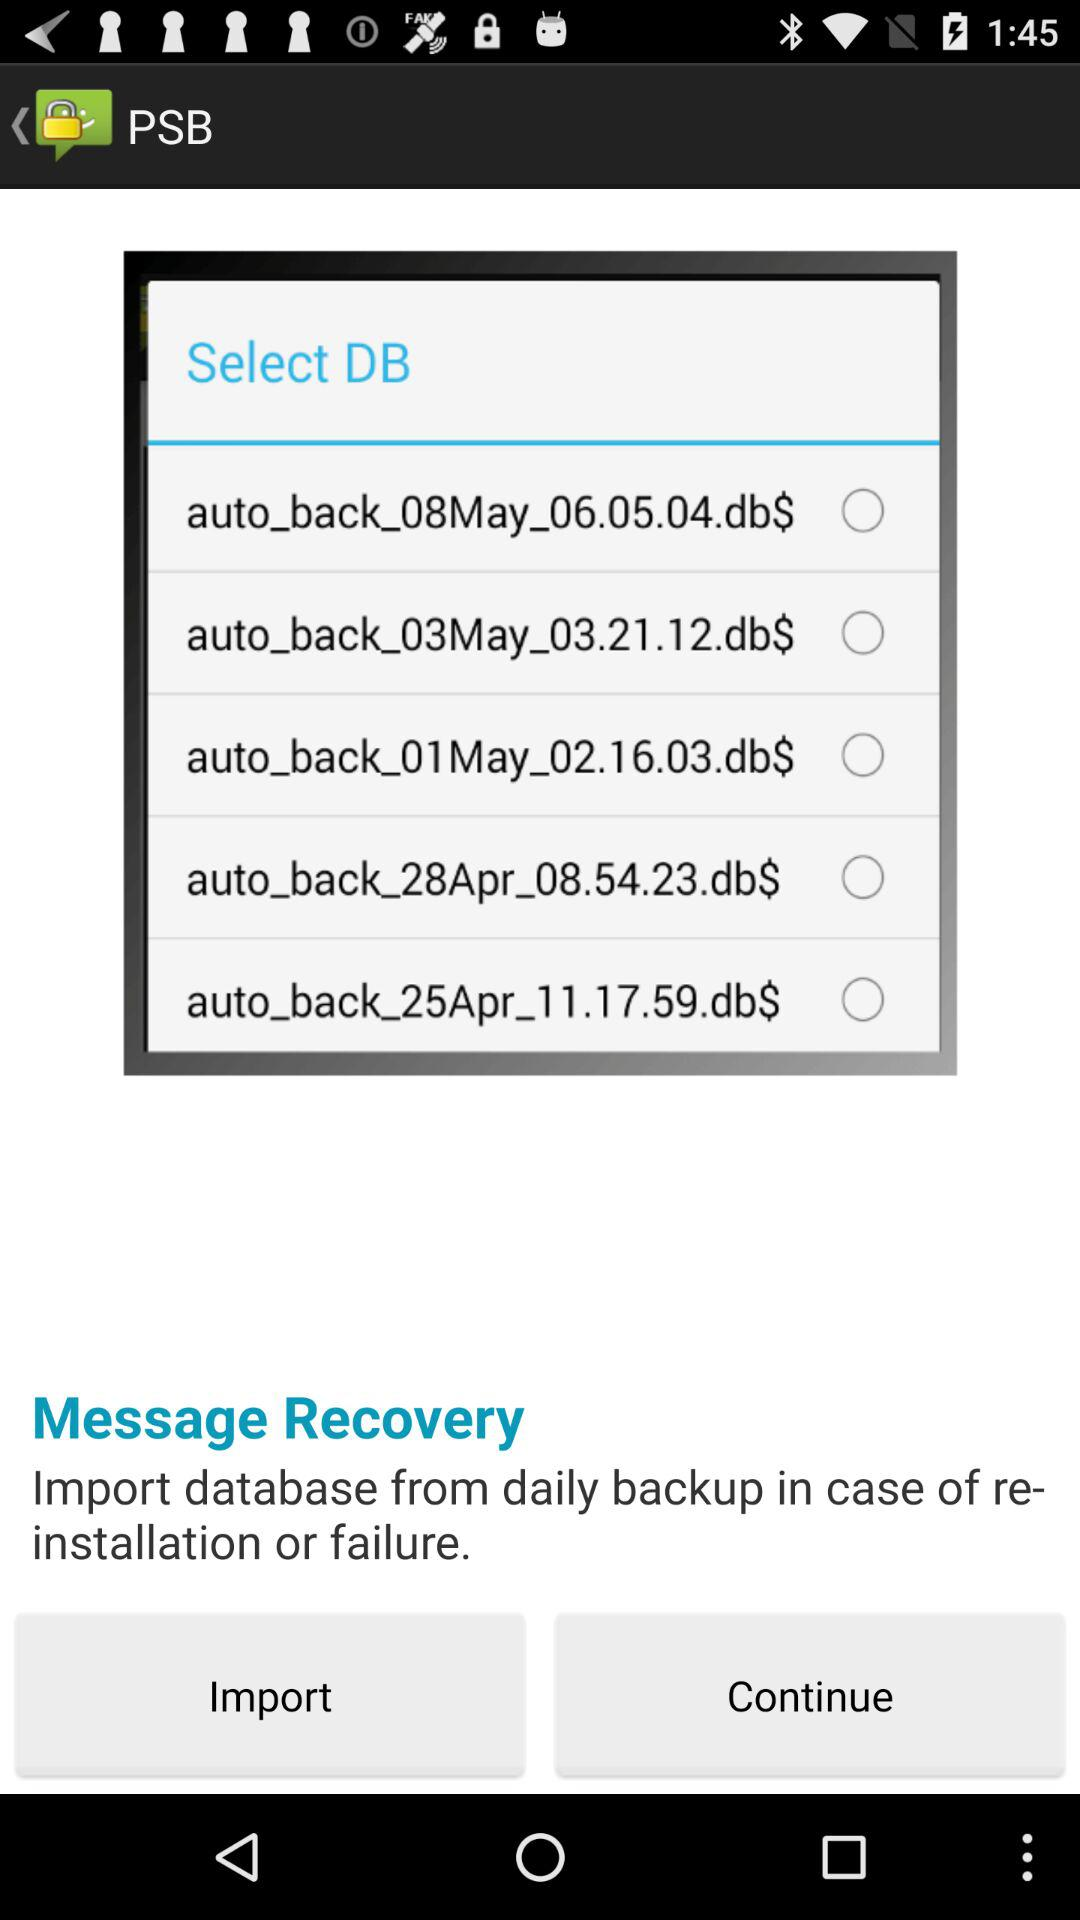Is there a pattern to the days backups are taken? Based on the image, backups are taken on a near-daily basis, with dates ranging from April 25th to May 8th, suggesting a systematic approach to data protection. It's common practice to schedule regular backups to minimize data loss in case of unexpected failures. 